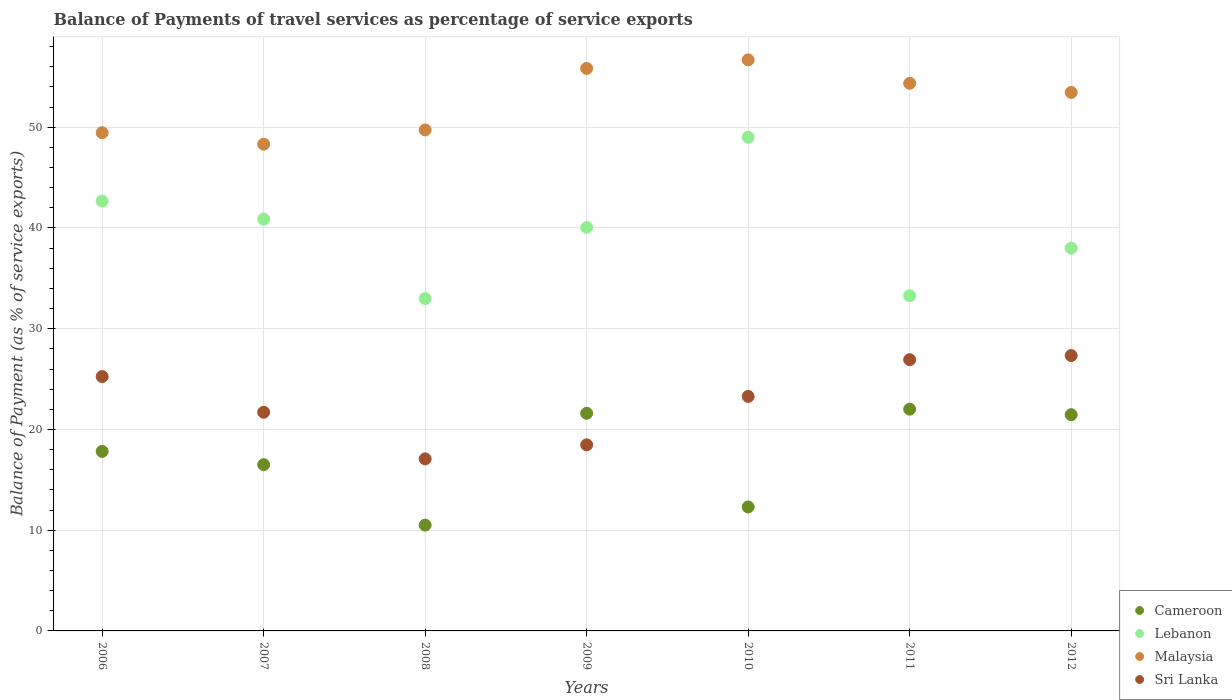How many different coloured dotlines are there?
Offer a terse response. 4. What is the balance of payments of travel services in Sri Lanka in 2008?
Your answer should be compact. 17.08. Across all years, what is the maximum balance of payments of travel services in Cameroon?
Offer a very short reply. 22.01. Across all years, what is the minimum balance of payments of travel services in Malaysia?
Offer a terse response. 48.32. In which year was the balance of payments of travel services in Cameroon maximum?
Give a very brief answer. 2011. In which year was the balance of payments of travel services in Malaysia minimum?
Offer a very short reply. 2007. What is the total balance of payments of travel services in Lebanon in the graph?
Provide a succinct answer. 276.89. What is the difference between the balance of payments of travel services in Malaysia in 2007 and that in 2010?
Keep it short and to the point. -8.37. What is the difference between the balance of payments of travel services in Malaysia in 2012 and the balance of payments of travel services in Cameroon in 2007?
Your response must be concise. 36.95. What is the average balance of payments of travel services in Lebanon per year?
Offer a terse response. 39.56. In the year 2011, what is the difference between the balance of payments of travel services in Malaysia and balance of payments of travel services in Cameroon?
Keep it short and to the point. 32.35. In how many years, is the balance of payments of travel services in Lebanon greater than 12 %?
Your answer should be very brief. 7. What is the ratio of the balance of payments of travel services in Sri Lanka in 2007 to that in 2012?
Offer a very short reply. 0.79. What is the difference between the highest and the second highest balance of payments of travel services in Malaysia?
Give a very brief answer. 0.85. What is the difference between the highest and the lowest balance of payments of travel services in Malaysia?
Offer a very short reply. 8.37. In how many years, is the balance of payments of travel services in Cameroon greater than the average balance of payments of travel services in Cameroon taken over all years?
Your answer should be compact. 4. Is the sum of the balance of payments of travel services in Cameroon in 2006 and 2012 greater than the maximum balance of payments of travel services in Sri Lanka across all years?
Give a very brief answer. Yes. Is it the case that in every year, the sum of the balance of payments of travel services in Malaysia and balance of payments of travel services in Lebanon  is greater than the sum of balance of payments of travel services in Cameroon and balance of payments of travel services in Sri Lanka?
Offer a very short reply. Yes. Is it the case that in every year, the sum of the balance of payments of travel services in Lebanon and balance of payments of travel services in Sri Lanka  is greater than the balance of payments of travel services in Malaysia?
Offer a very short reply. Yes. Is the balance of payments of travel services in Malaysia strictly greater than the balance of payments of travel services in Sri Lanka over the years?
Keep it short and to the point. Yes. Is the balance of payments of travel services in Sri Lanka strictly less than the balance of payments of travel services in Cameroon over the years?
Your answer should be very brief. No. How many dotlines are there?
Ensure brevity in your answer.  4. Are the values on the major ticks of Y-axis written in scientific E-notation?
Provide a short and direct response. No. Does the graph contain grids?
Offer a very short reply. Yes. How are the legend labels stacked?
Your response must be concise. Vertical. What is the title of the graph?
Provide a short and direct response. Balance of Payments of travel services as percentage of service exports. Does "High income: OECD" appear as one of the legend labels in the graph?
Your answer should be compact. No. What is the label or title of the Y-axis?
Make the answer very short. Balance of Payment (as % of service exports). What is the Balance of Payment (as % of service exports) in Cameroon in 2006?
Your response must be concise. 17.82. What is the Balance of Payment (as % of service exports) in Lebanon in 2006?
Your answer should be very brief. 42.68. What is the Balance of Payment (as % of service exports) of Malaysia in 2006?
Ensure brevity in your answer.  49.46. What is the Balance of Payment (as % of service exports) of Sri Lanka in 2006?
Your response must be concise. 25.25. What is the Balance of Payment (as % of service exports) of Cameroon in 2007?
Your response must be concise. 16.51. What is the Balance of Payment (as % of service exports) of Lebanon in 2007?
Your answer should be very brief. 40.89. What is the Balance of Payment (as % of service exports) of Malaysia in 2007?
Offer a terse response. 48.32. What is the Balance of Payment (as % of service exports) in Sri Lanka in 2007?
Your response must be concise. 21.71. What is the Balance of Payment (as % of service exports) in Cameroon in 2008?
Make the answer very short. 10.5. What is the Balance of Payment (as % of service exports) in Lebanon in 2008?
Keep it short and to the point. 33. What is the Balance of Payment (as % of service exports) in Malaysia in 2008?
Your response must be concise. 49.73. What is the Balance of Payment (as % of service exports) in Sri Lanka in 2008?
Provide a succinct answer. 17.08. What is the Balance of Payment (as % of service exports) in Cameroon in 2009?
Keep it short and to the point. 21.6. What is the Balance of Payment (as % of service exports) of Lebanon in 2009?
Offer a very short reply. 40.06. What is the Balance of Payment (as % of service exports) of Malaysia in 2009?
Give a very brief answer. 55.84. What is the Balance of Payment (as % of service exports) in Sri Lanka in 2009?
Your answer should be very brief. 18.47. What is the Balance of Payment (as % of service exports) of Cameroon in 2010?
Ensure brevity in your answer.  12.31. What is the Balance of Payment (as % of service exports) of Lebanon in 2010?
Give a very brief answer. 49.01. What is the Balance of Payment (as % of service exports) in Malaysia in 2010?
Make the answer very short. 56.69. What is the Balance of Payment (as % of service exports) in Sri Lanka in 2010?
Make the answer very short. 23.28. What is the Balance of Payment (as % of service exports) of Cameroon in 2011?
Give a very brief answer. 22.01. What is the Balance of Payment (as % of service exports) in Lebanon in 2011?
Your answer should be compact. 33.27. What is the Balance of Payment (as % of service exports) of Malaysia in 2011?
Provide a succinct answer. 54.36. What is the Balance of Payment (as % of service exports) of Sri Lanka in 2011?
Make the answer very short. 26.92. What is the Balance of Payment (as % of service exports) of Cameroon in 2012?
Provide a succinct answer. 21.46. What is the Balance of Payment (as % of service exports) in Lebanon in 2012?
Your answer should be compact. 38. What is the Balance of Payment (as % of service exports) of Malaysia in 2012?
Provide a short and direct response. 53.46. What is the Balance of Payment (as % of service exports) of Sri Lanka in 2012?
Your response must be concise. 27.34. Across all years, what is the maximum Balance of Payment (as % of service exports) in Cameroon?
Your answer should be compact. 22.01. Across all years, what is the maximum Balance of Payment (as % of service exports) of Lebanon?
Your response must be concise. 49.01. Across all years, what is the maximum Balance of Payment (as % of service exports) in Malaysia?
Your answer should be compact. 56.69. Across all years, what is the maximum Balance of Payment (as % of service exports) in Sri Lanka?
Keep it short and to the point. 27.34. Across all years, what is the minimum Balance of Payment (as % of service exports) of Cameroon?
Offer a very short reply. 10.5. Across all years, what is the minimum Balance of Payment (as % of service exports) of Lebanon?
Offer a very short reply. 33. Across all years, what is the minimum Balance of Payment (as % of service exports) in Malaysia?
Your answer should be very brief. 48.32. Across all years, what is the minimum Balance of Payment (as % of service exports) in Sri Lanka?
Provide a succinct answer. 17.08. What is the total Balance of Payment (as % of service exports) of Cameroon in the graph?
Offer a very short reply. 122.22. What is the total Balance of Payment (as % of service exports) of Lebanon in the graph?
Ensure brevity in your answer.  276.89. What is the total Balance of Payment (as % of service exports) of Malaysia in the graph?
Your answer should be compact. 367.86. What is the total Balance of Payment (as % of service exports) in Sri Lanka in the graph?
Give a very brief answer. 160.05. What is the difference between the Balance of Payment (as % of service exports) of Cameroon in 2006 and that in 2007?
Provide a short and direct response. 1.31. What is the difference between the Balance of Payment (as % of service exports) in Lebanon in 2006 and that in 2007?
Keep it short and to the point. 1.79. What is the difference between the Balance of Payment (as % of service exports) in Malaysia in 2006 and that in 2007?
Keep it short and to the point. 1.14. What is the difference between the Balance of Payment (as % of service exports) in Sri Lanka in 2006 and that in 2007?
Provide a short and direct response. 3.54. What is the difference between the Balance of Payment (as % of service exports) of Cameroon in 2006 and that in 2008?
Your answer should be very brief. 7.31. What is the difference between the Balance of Payment (as % of service exports) in Lebanon in 2006 and that in 2008?
Keep it short and to the point. 9.68. What is the difference between the Balance of Payment (as % of service exports) of Malaysia in 2006 and that in 2008?
Your answer should be compact. -0.27. What is the difference between the Balance of Payment (as % of service exports) in Sri Lanka in 2006 and that in 2008?
Keep it short and to the point. 8.17. What is the difference between the Balance of Payment (as % of service exports) in Cameroon in 2006 and that in 2009?
Offer a very short reply. -3.79. What is the difference between the Balance of Payment (as % of service exports) in Lebanon in 2006 and that in 2009?
Your answer should be very brief. 2.62. What is the difference between the Balance of Payment (as % of service exports) of Malaysia in 2006 and that in 2009?
Make the answer very short. -6.38. What is the difference between the Balance of Payment (as % of service exports) of Sri Lanka in 2006 and that in 2009?
Offer a terse response. 6.78. What is the difference between the Balance of Payment (as % of service exports) in Cameroon in 2006 and that in 2010?
Your answer should be compact. 5.51. What is the difference between the Balance of Payment (as % of service exports) of Lebanon in 2006 and that in 2010?
Offer a terse response. -6.33. What is the difference between the Balance of Payment (as % of service exports) in Malaysia in 2006 and that in 2010?
Your response must be concise. -7.23. What is the difference between the Balance of Payment (as % of service exports) of Sri Lanka in 2006 and that in 2010?
Keep it short and to the point. 1.97. What is the difference between the Balance of Payment (as % of service exports) in Cameroon in 2006 and that in 2011?
Provide a succinct answer. -4.2. What is the difference between the Balance of Payment (as % of service exports) of Lebanon in 2006 and that in 2011?
Make the answer very short. 9.41. What is the difference between the Balance of Payment (as % of service exports) in Malaysia in 2006 and that in 2011?
Offer a terse response. -4.9. What is the difference between the Balance of Payment (as % of service exports) of Sri Lanka in 2006 and that in 2011?
Your answer should be very brief. -1.67. What is the difference between the Balance of Payment (as % of service exports) of Cameroon in 2006 and that in 2012?
Your answer should be compact. -3.65. What is the difference between the Balance of Payment (as % of service exports) of Lebanon in 2006 and that in 2012?
Your answer should be compact. 4.68. What is the difference between the Balance of Payment (as % of service exports) in Malaysia in 2006 and that in 2012?
Your response must be concise. -3.99. What is the difference between the Balance of Payment (as % of service exports) of Sri Lanka in 2006 and that in 2012?
Provide a short and direct response. -2.09. What is the difference between the Balance of Payment (as % of service exports) in Cameroon in 2007 and that in 2008?
Keep it short and to the point. 6. What is the difference between the Balance of Payment (as % of service exports) of Lebanon in 2007 and that in 2008?
Ensure brevity in your answer.  7.89. What is the difference between the Balance of Payment (as % of service exports) of Malaysia in 2007 and that in 2008?
Offer a very short reply. -1.41. What is the difference between the Balance of Payment (as % of service exports) of Sri Lanka in 2007 and that in 2008?
Ensure brevity in your answer.  4.63. What is the difference between the Balance of Payment (as % of service exports) of Cameroon in 2007 and that in 2009?
Provide a succinct answer. -5.1. What is the difference between the Balance of Payment (as % of service exports) of Lebanon in 2007 and that in 2009?
Offer a very short reply. 0.83. What is the difference between the Balance of Payment (as % of service exports) in Malaysia in 2007 and that in 2009?
Ensure brevity in your answer.  -7.52. What is the difference between the Balance of Payment (as % of service exports) of Sri Lanka in 2007 and that in 2009?
Offer a terse response. 3.23. What is the difference between the Balance of Payment (as % of service exports) in Cameroon in 2007 and that in 2010?
Your answer should be compact. 4.2. What is the difference between the Balance of Payment (as % of service exports) of Lebanon in 2007 and that in 2010?
Make the answer very short. -8.12. What is the difference between the Balance of Payment (as % of service exports) of Malaysia in 2007 and that in 2010?
Offer a terse response. -8.37. What is the difference between the Balance of Payment (as % of service exports) in Sri Lanka in 2007 and that in 2010?
Your response must be concise. -1.57. What is the difference between the Balance of Payment (as % of service exports) of Cameroon in 2007 and that in 2011?
Provide a succinct answer. -5.51. What is the difference between the Balance of Payment (as % of service exports) in Lebanon in 2007 and that in 2011?
Offer a terse response. 7.62. What is the difference between the Balance of Payment (as % of service exports) of Malaysia in 2007 and that in 2011?
Keep it short and to the point. -6.04. What is the difference between the Balance of Payment (as % of service exports) in Sri Lanka in 2007 and that in 2011?
Provide a short and direct response. -5.22. What is the difference between the Balance of Payment (as % of service exports) in Cameroon in 2007 and that in 2012?
Make the answer very short. -4.96. What is the difference between the Balance of Payment (as % of service exports) of Lebanon in 2007 and that in 2012?
Make the answer very short. 2.89. What is the difference between the Balance of Payment (as % of service exports) of Malaysia in 2007 and that in 2012?
Offer a very short reply. -5.13. What is the difference between the Balance of Payment (as % of service exports) in Sri Lanka in 2007 and that in 2012?
Your answer should be compact. -5.63. What is the difference between the Balance of Payment (as % of service exports) of Cameroon in 2008 and that in 2009?
Your response must be concise. -11.1. What is the difference between the Balance of Payment (as % of service exports) of Lebanon in 2008 and that in 2009?
Provide a succinct answer. -7.06. What is the difference between the Balance of Payment (as % of service exports) in Malaysia in 2008 and that in 2009?
Ensure brevity in your answer.  -6.11. What is the difference between the Balance of Payment (as % of service exports) in Sri Lanka in 2008 and that in 2009?
Your answer should be very brief. -1.39. What is the difference between the Balance of Payment (as % of service exports) of Cameroon in 2008 and that in 2010?
Your answer should be compact. -1.8. What is the difference between the Balance of Payment (as % of service exports) in Lebanon in 2008 and that in 2010?
Offer a terse response. -16.01. What is the difference between the Balance of Payment (as % of service exports) of Malaysia in 2008 and that in 2010?
Offer a terse response. -6.96. What is the difference between the Balance of Payment (as % of service exports) in Sri Lanka in 2008 and that in 2010?
Make the answer very short. -6.2. What is the difference between the Balance of Payment (as % of service exports) in Cameroon in 2008 and that in 2011?
Your response must be concise. -11.51. What is the difference between the Balance of Payment (as % of service exports) of Lebanon in 2008 and that in 2011?
Make the answer very short. -0.27. What is the difference between the Balance of Payment (as % of service exports) of Malaysia in 2008 and that in 2011?
Offer a terse response. -4.63. What is the difference between the Balance of Payment (as % of service exports) of Sri Lanka in 2008 and that in 2011?
Give a very brief answer. -9.84. What is the difference between the Balance of Payment (as % of service exports) of Cameroon in 2008 and that in 2012?
Provide a short and direct response. -10.96. What is the difference between the Balance of Payment (as % of service exports) of Lebanon in 2008 and that in 2012?
Make the answer very short. -5. What is the difference between the Balance of Payment (as % of service exports) of Malaysia in 2008 and that in 2012?
Keep it short and to the point. -3.72. What is the difference between the Balance of Payment (as % of service exports) of Sri Lanka in 2008 and that in 2012?
Provide a succinct answer. -10.26. What is the difference between the Balance of Payment (as % of service exports) in Cameroon in 2009 and that in 2010?
Provide a succinct answer. 9.3. What is the difference between the Balance of Payment (as % of service exports) in Lebanon in 2009 and that in 2010?
Your answer should be compact. -8.95. What is the difference between the Balance of Payment (as % of service exports) of Malaysia in 2009 and that in 2010?
Keep it short and to the point. -0.85. What is the difference between the Balance of Payment (as % of service exports) of Sri Lanka in 2009 and that in 2010?
Ensure brevity in your answer.  -4.8. What is the difference between the Balance of Payment (as % of service exports) of Cameroon in 2009 and that in 2011?
Provide a succinct answer. -0.41. What is the difference between the Balance of Payment (as % of service exports) of Lebanon in 2009 and that in 2011?
Ensure brevity in your answer.  6.79. What is the difference between the Balance of Payment (as % of service exports) of Malaysia in 2009 and that in 2011?
Keep it short and to the point. 1.48. What is the difference between the Balance of Payment (as % of service exports) of Sri Lanka in 2009 and that in 2011?
Offer a terse response. -8.45. What is the difference between the Balance of Payment (as % of service exports) of Cameroon in 2009 and that in 2012?
Provide a succinct answer. 0.14. What is the difference between the Balance of Payment (as % of service exports) in Lebanon in 2009 and that in 2012?
Provide a short and direct response. 2.06. What is the difference between the Balance of Payment (as % of service exports) in Malaysia in 2009 and that in 2012?
Provide a succinct answer. 2.38. What is the difference between the Balance of Payment (as % of service exports) in Sri Lanka in 2009 and that in 2012?
Make the answer very short. -8.86. What is the difference between the Balance of Payment (as % of service exports) of Cameroon in 2010 and that in 2011?
Offer a terse response. -9.71. What is the difference between the Balance of Payment (as % of service exports) in Lebanon in 2010 and that in 2011?
Ensure brevity in your answer.  15.74. What is the difference between the Balance of Payment (as % of service exports) of Malaysia in 2010 and that in 2011?
Offer a very short reply. 2.33. What is the difference between the Balance of Payment (as % of service exports) in Sri Lanka in 2010 and that in 2011?
Provide a succinct answer. -3.65. What is the difference between the Balance of Payment (as % of service exports) of Cameroon in 2010 and that in 2012?
Your answer should be very brief. -9.16. What is the difference between the Balance of Payment (as % of service exports) in Lebanon in 2010 and that in 2012?
Keep it short and to the point. 11.01. What is the difference between the Balance of Payment (as % of service exports) of Malaysia in 2010 and that in 2012?
Your answer should be compact. 3.24. What is the difference between the Balance of Payment (as % of service exports) of Sri Lanka in 2010 and that in 2012?
Ensure brevity in your answer.  -4.06. What is the difference between the Balance of Payment (as % of service exports) of Cameroon in 2011 and that in 2012?
Make the answer very short. 0.55. What is the difference between the Balance of Payment (as % of service exports) in Lebanon in 2011 and that in 2012?
Offer a very short reply. -4.73. What is the difference between the Balance of Payment (as % of service exports) of Malaysia in 2011 and that in 2012?
Provide a succinct answer. 0.91. What is the difference between the Balance of Payment (as % of service exports) of Sri Lanka in 2011 and that in 2012?
Offer a terse response. -0.41. What is the difference between the Balance of Payment (as % of service exports) in Cameroon in 2006 and the Balance of Payment (as % of service exports) in Lebanon in 2007?
Provide a succinct answer. -23.07. What is the difference between the Balance of Payment (as % of service exports) in Cameroon in 2006 and the Balance of Payment (as % of service exports) in Malaysia in 2007?
Your response must be concise. -30.5. What is the difference between the Balance of Payment (as % of service exports) of Cameroon in 2006 and the Balance of Payment (as % of service exports) of Sri Lanka in 2007?
Offer a terse response. -3.89. What is the difference between the Balance of Payment (as % of service exports) of Lebanon in 2006 and the Balance of Payment (as % of service exports) of Malaysia in 2007?
Your answer should be very brief. -5.65. What is the difference between the Balance of Payment (as % of service exports) of Lebanon in 2006 and the Balance of Payment (as % of service exports) of Sri Lanka in 2007?
Your answer should be very brief. 20.97. What is the difference between the Balance of Payment (as % of service exports) of Malaysia in 2006 and the Balance of Payment (as % of service exports) of Sri Lanka in 2007?
Make the answer very short. 27.75. What is the difference between the Balance of Payment (as % of service exports) in Cameroon in 2006 and the Balance of Payment (as % of service exports) in Lebanon in 2008?
Provide a succinct answer. -15.18. What is the difference between the Balance of Payment (as % of service exports) of Cameroon in 2006 and the Balance of Payment (as % of service exports) of Malaysia in 2008?
Offer a very short reply. -31.91. What is the difference between the Balance of Payment (as % of service exports) in Cameroon in 2006 and the Balance of Payment (as % of service exports) in Sri Lanka in 2008?
Provide a succinct answer. 0.74. What is the difference between the Balance of Payment (as % of service exports) of Lebanon in 2006 and the Balance of Payment (as % of service exports) of Malaysia in 2008?
Make the answer very short. -7.06. What is the difference between the Balance of Payment (as % of service exports) of Lebanon in 2006 and the Balance of Payment (as % of service exports) of Sri Lanka in 2008?
Provide a succinct answer. 25.6. What is the difference between the Balance of Payment (as % of service exports) in Malaysia in 2006 and the Balance of Payment (as % of service exports) in Sri Lanka in 2008?
Make the answer very short. 32.38. What is the difference between the Balance of Payment (as % of service exports) of Cameroon in 2006 and the Balance of Payment (as % of service exports) of Lebanon in 2009?
Your answer should be very brief. -22.24. What is the difference between the Balance of Payment (as % of service exports) of Cameroon in 2006 and the Balance of Payment (as % of service exports) of Malaysia in 2009?
Offer a terse response. -38.02. What is the difference between the Balance of Payment (as % of service exports) of Cameroon in 2006 and the Balance of Payment (as % of service exports) of Sri Lanka in 2009?
Ensure brevity in your answer.  -0.66. What is the difference between the Balance of Payment (as % of service exports) in Lebanon in 2006 and the Balance of Payment (as % of service exports) in Malaysia in 2009?
Offer a terse response. -13.16. What is the difference between the Balance of Payment (as % of service exports) of Lebanon in 2006 and the Balance of Payment (as % of service exports) of Sri Lanka in 2009?
Give a very brief answer. 24.2. What is the difference between the Balance of Payment (as % of service exports) in Malaysia in 2006 and the Balance of Payment (as % of service exports) in Sri Lanka in 2009?
Your answer should be compact. 30.99. What is the difference between the Balance of Payment (as % of service exports) in Cameroon in 2006 and the Balance of Payment (as % of service exports) in Lebanon in 2010?
Provide a short and direct response. -31.19. What is the difference between the Balance of Payment (as % of service exports) in Cameroon in 2006 and the Balance of Payment (as % of service exports) in Malaysia in 2010?
Your answer should be compact. -38.87. What is the difference between the Balance of Payment (as % of service exports) in Cameroon in 2006 and the Balance of Payment (as % of service exports) in Sri Lanka in 2010?
Offer a terse response. -5.46. What is the difference between the Balance of Payment (as % of service exports) of Lebanon in 2006 and the Balance of Payment (as % of service exports) of Malaysia in 2010?
Offer a terse response. -14.02. What is the difference between the Balance of Payment (as % of service exports) in Lebanon in 2006 and the Balance of Payment (as % of service exports) in Sri Lanka in 2010?
Give a very brief answer. 19.4. What is the difference between the Balance of Payment (as % of service exports) of Malaysia in 2006 and the Balance of Payment (as % of service exports) of Sri Lanka in 2010?
Keep it short and to the point. 26.18. What is the difference between the Balance of Payment (as % of service exports) of Cameroon in 2006 and the Balance of Payment (as % of service exports) of Lebanon in 2011?
Give a very brief answer. -15.45. What is the difference between the Balance of Payment (as % of service exports) in Cameroon in 2006 and the Balance of Payment (as % of service exports) in Malaysia in 2011?
Give a very brief answer. -36.54. What is the difference between the Balance of Payment (as % of service exports) of Cameroon in 2006 and the Balance of Payment (as % of service exports) of Sri Lanka in 2011?
Provide a short and direct response. -9.11. What is the difference between the Balance of Payment (as % of service exports) in Lebanon in 2006 and the Balance of Payment (as % of service exports) in Malaysia in 2011?
Provide a succinct answer. -11.69. What is the difference between the Balance of Payment (as % of service exports) in Lebanon in 2006 and the Balance of Payment (as % of service exports) in Sri Lanka in 2011?
Your answer should be compact. 15.75. What is the difference between the Balance of Payment (as % of service exports) in Malaysia in 2006 and the Balance of Payment (as % of service exports) in Sri Lanka in 2011?
Your answer should be very brief. 22.54. What is the difference between the Balance of Payment (as % of service exports) in Cameroon in 2006 and the Balance of Payment (as % of service exports) in Lebanon in 2012?
Keep it short and to the point. -20.18. What is the difference between the Balance of Payment (as % of service exports) in Cameroon in 2006 and the Balance of Payment (as % of service exports) in Malaysia in 2012?
Your response must be concise. -35.64. What is the difference between the Balance of Payment (as % of service exports) in Cameroon in 2006 and the Balance of Payment (as % of service exports) in Sri Lanka in 2012?
Provide a succinct answer. -9.52. What is the difference between the Balance of Payment (as % of service exports) in Lebanon in 2006 and the Balance of Payment (as % of service exports) in Malaysia in 2012?
Your response must be concise. -10.78. What is the difference between the Balance of Payment (as % of service exports) in Lebanon in 2006 and the Balance of Payment (as % of service exports) in Sri Lanka in 2012?
Your response must be concise. 15.34. What is the difference between the Balance of Payment (as % of service exports) of Malaysia in 2006 and the Balance of Payment (as % of service exports) of Sri Lanka in 2012?
Your answer should be compact. 22.13. What is the difference between the Balance of Payment (as % of service exports) of Cameroon in 2007 and the Balance of Payment (as % of service exports) of Lebanon in 2008?
Ensure brevity in your answer.  -16.49. What is the difference between the Balance of Payment (as % of service exports) in Cameroon in 2007 and the Balance of Payment (as % of service exports) in Malaysia in 2008?
Offer a terse response. -33.22. What is the difference between the Balance of Payment (as % of service exports) of Cameroon in 2007 and the Balance of Payment (as % of service exports) of Sri Lanka in 2008?
Provide a short and direct response. -0.57. What is the difference between the Balance of Payment (as % of service exports) in Lebanon in 2007 and the Balance of Payment (as % of service exports) in Malaysia in 2008?
Your answer should be compact. -8.85. What is the difference between the Balance of Payment (as % of service exports) of Lebanon in 2007 and the Balance of Payment (as % of service exports) of Sri Lanka in 2008?
Offer a very short reply. 23.81. What is the difference between the Balance of Payment (as % of service exports) in Malaysia in 2007 and the Balance of Payment (as % of service exports) in Sri Lanka in 2008?
Make the answer very short. 31.24. What is the difference between the Balance of Payment (as % of service exports) of Cameroon in 2007 and the Balance of Payment (as % of service exports) of Lebanon in 2009?
Provide a succinct answer. -23.55. What is the difference between the Balance of Payment (as % of service exports) of Cameroon in 2007 and the Balance of Payment (as % of service exports) of Malaysia in 2009?
Your response must be concise. -39.33. What is the difference between the Balance of Payment (as % of service exports) in Cameroon in 2007 and the Balance of Payment (as % of service exports) in Sri Lanka in 2009?
Keep it short and to the point. -1.97. What is the difference between the Balance of Payment (as % of service exports) of Lebanon in 2007 and the Balance of Payment (as % of service exports) of Malaysia in 2009?
Your answer should be compact. -14.95. What is the difference between the Balance of Payment (as % of service exports) in Lebanon in 2007 and the Balance of Payment (as % of service exports) in Sri Lanka in 2009?
Ensure brevity in your answer.  22.41. What is the difference between the Balance of Payment (as % of service exports) of Malaysia in 2007 and the Balance of Payment (as % of service exports) of Sri Lanka in 2009?
Provide a succinct answer. 29.85. What is the difference between the Balance of Payment (as % of service exports) of Cameroon in 2007 and the Balance of Payment (as % of service exports) of Lebanon in 2010?
Keep it short and to the point. -32.5. What is the difference between the Balance of Payment (as % of service exports) of Cameroon in 2007 and the Balance of Payment (as % of service exports) of Malaysia in 2010?
Give a very brief answer. -40.18. What is the difference between the Balance of Payment (as % of service exports) in Cameroon in 2007 and the Balance of Payment (as % of service exports) in Sri Lanka in 2010?
Ensure brevity in your answer.  -6.77. What is the difference between the Balance of Payment (as % of service exports) of Lebanon in 2007 and the Balance of Payment (as % of service exports) of Malaysia in 2010?
Give a very brief answer. -15.81. What is the difference between the Balance of Payment (as % of service exports) in Lebanon in 2007 and the Balance of Payment (as % of service exports) in Sri Lanka in 2010?
Make the answer very short. 17.61. What is the difference between the Balance of Payment (as % of service exports) of Malaysia in 2007 and the Balance of Payment (as % of service exports) of Sri Lanka in 2010?
Give a very brief answer. 25.04. What is the difference between the Balance of Payment (as % of service exports) in Cameroon in 2007 and the Balance of Payment (as % of service exports) in Lebanon in 2011?
Provide a succinct answer. -16.76. What is the difference between the Balance of Payment (as % of service exports) of Cameroon in 2007 and the Balance of Payment (as % of service exports) of Malaysia in 2011?
Keep it short and to the point. -37.85. What is the difference between the Balance of Payment (as % of service exports) of Cameroon in 2007 and the Balance of Payment (as % of service exports) of Sri Lanka in 2011?
Offer a terse response. -10.42. What is the difference between the Balance of Payment (as % of service exports) in Lebanon in 2007 and the Balance of Payment (as % of service exports) in Malaysia in 2011?
Give a very brief answer. -13.48. What is the difference between the Balance of Payment (as % of service exports) of Lebanon in 2007 and the Balance of Payment (as % of service exports) of Sri Lanka in 2011?
Offer a very short reply. 13.96. What is the difference between the Balance of Payment (as % of service exports) of Malaysia in 2007 and the Balance of Payment (as % of service exports) of Sri Lanka in 2011?
Your answer should be very brief. 21.4. What is the difference between the Balance of Payment (as % of service exports) in Cameroon in 2007 and the Balance of Payment (as % of service exports) in Lebanon in 2012?
Provide a succinct answer. -21.49. What is the difference between the Balance of Payment (as % of service exports) in Cameroon in 2007 and the Balance of Payment (as % of service exports) in Malaysia in 2012?
Make the answer very short. -36.95. What is the difference between the Balance of Payment (as % of service exports) in Cameroon in 2007 and the Balance of Payment (as % of service exports) in Sri Lanka in 2012?
Provide a succinct answer. -10.83. What is the difference between the Balance of Payment (as % of service exports) in Lebanon in 2007 and the Balance of Payment (as % of service exports) in Malaysia in 2012?
Offer a terse response. -12.57. What is the difference between the Balance of Payment (as % of service exports) of Lebanon in 2007 and the Balance of Payment (as % of service exports) of Sri Lanka in 2012?
Provide a short and direct response. 13.55. What is the difference between the Balance of Payment (as % of service exports) of Malaysia in 2007 and the Balance of Payment (as % of service exports) of Sri Lanka in 2012?
Provide a short and direct response. 20.98. What is the difference between the Balance of Payment (as % of service exports) in Cameroon in 2008 and the Balance of Payment (as % of service exports) in Lebanon in 2009?
Keep it short and to the point. -29.56. What is the difference between the Balance of Payment (as % of service exports) in Cameroon in 2008 and the Balance of Payment (as % of service exports) in Malaysia in 2009?
Provide a short and direct response. -45.34. What is the difference between the Balance of Payment (as % of service exports) in Cameroon in 2008 and the Balance of Payment (as % of service exports) in Sri Lanka in 2009?
Give a very brief answer. -7.97. What is the difference between the Balance of Payment (as % of service exports) of Lebanon in 2008 and the Balance of Payment (as % of service exports) of Malaysia in 2009?
Provide a succinct answer. -22.84. What is the difference between the Balance of Payment (as % of service exports) of Lebanon in 2008 and the Balance of Payment (as % of service exports) of Sri Lanka in 2009?
Offer a very short reply. 14.52. What is the difference between the Balance of Payment (as % of service exports) of Malaysia in 2008 and the Balance of Payment (as % of service exports) of Sri Lanka in 2009?
Your answer should be compact. 31.26. What is the difference between the Balance of Payment (as % of service exports) in Cameroon in 2008 and the Balance of Payment (as % of service exports) in Lebanon in 2010?
Offer a very short reply. -38.5. What is the difference between the Balance of Payment (as % of service exports) of Cameroon in 2008 and the Balance of Payment (as % of service exports) of Malaysia in 2010?
Provide a short and direct response. -46.19. What is the difference between the Balance of Payment (as % of service exports) in Cameroon in 2008 and the Balance of Payment (as % of service exports) in Sri Lanka in 2010?
Give a very brief answer. -12.77. What is the difference between the Balance of Payment (as % of service exports) of Lebanon in 2008 and the Balance of Payment (as % of service exports) of Malaysia in 2010?
Offer a very short reply. -23.7. What is the difference between the Balance of Payment (as % of service exports) in Lebanon in 2008 and the Balance of Payment (as % of service exports) in Sri Lanka in 2010?
Offer a very short reply. 9.72. What is the difference between the Balance of Payment (as % of service exports) in Malaysia in 2008 and the Balance of Payment (as % of service exports) in Sri Lanka in 2010?
Provide a short and direct response. 26.45. What is the difference between the Balance of Payment (as % of service exports) of Cameroon in 2008 and the Balance of Payment (as % of service exports) of Lebanon in 2011?
Give a very brief answer. -22.76. What is the difference between the Balance of Payment (as % of service exports) of Cameroon in 2008 and the Balance of Payment (as % of service exports) of Malaysia in 2011?
Provide a short and direct response. -43.86. What is the difference between the Balance of Payment (as % of service exports) in Cameroon in 2008 and the Balance of Payment (as % of service exports) in Sri Lanka in 2011?
Your response must be concise. -16.42. What is the difference between the Balance of Payment (as % of service exports) of Lebanon in 2008 and the Balance of Payment (as % of service exports) of Malaysia in 2011?
Provide a succinct answer. -21.37. What is the difference between the Balance of Payment (as % of service exports) of Lebanon in 2008 and the Balance of Payment (as % of service exports) of Sri Lanka in 2011?
Keep it short and to the point. 6.07. What is the difference between the Balance of Payment (as % of service exports) in Malaysia in 2008 and the Balance of Payment (as % of service exports) in Sri Lanka in 2011?
Your answer should be very brief. 22.81. What is the difference between the Balance of Payment (as % of service exports) of Cameroon in 2008 and the Balance of Payment (as % of service exports) of Lebanon in 2012?
Your response must be concise. -27.5. What is the difference between the Balance of Payment (as % of service exports) of Cameroon in 2008 and the Balance of Payment (as % of service exports) of Malaysia in 2012?
Keep it short and to the point. -42.95. What is the difference between the Balance of Payment (as % of service exports) of Cameroon in 2008 and the Balance of Payment (as % of service exports) of Sri Lanka in 2012?
Your response must be concise. -16.83. What is the difference between the Balance of Payment (as % of service exports) of Lebanon in 2008 and the Balance of Payment (as % of service exports) of Malaysia in 2012?
Give a very brief answer. -20.46. What is the difference between the Balance of Payment (as % of service exports) of Lebanon in 2008 and the Balance of Payment (as % of service exports) of Sri Lanka in 2012?
Offer a very short reply. 5.66. What is the difference between the Balance of Payment (as % of service exports) of Malaysia in 2008 and the Balance of Payment (as % of service exports) of Sri Lanka in 2012?
Offer a very short reply. 22.4. What is the difference between the Balance of Payment (as % of service exports) of Cameroon in 2009 and the Balance of Payment (as % of service exports) of Lebanon in 2010?
Make the answer very short. -27.4. What is the difference between the Balance of Payment (as % of service exports) of Cameroon in 2009 and the Balance of Payment (as % of service exports) of Malaysia in 2010?
Provide a succinct answer. -35.09. What is the difference between the Balance of Payment (as % of service exports) of Cameroon in 2009 and the Balance of Payment (as % of service exports) of Sri Lanka in 2010?
Your answer should be compact. -1.67. What is the difference between the Balance of Payment (as % of service exports) in Lebanon in 2009 and the Balance of Payment (as % of service exports) in Malaysia in 2010?
Keep it short and to the point. -16.63. What is the difference between the Balance of Payment (as % of service exports) of Lebanon in 2009 and the Balance of Payment (as % of service exports) of Sri Lanka in 2010?
Make the answer very short. 16.78. What is the difference between the Balance of Payment (as % of service exports) in Malaysia in 2009 and the Balance of Payment (as % of service exports) in Sri Lanka in 2010?
Your answer should be very brief. 32.56. What is the difference between the Balance of Payment (as % of service exports) of Cameroon in 2009 and the Balance of Payment (as % of service exports) of Lebanon in 2011?
Your answer should be compact. -11.66. What is the difference between the Balance of Payment (as % of service exports) of Cameroon in 2009 and the Balance of Payment (as % of service exports) of Malaysia in 2011?
Your answer should be very brief. -32.76. What is the difference between the Balance of Payment (as % of service exports) of Cameroon in 2009 and the Balance of Payment (as % of service exports) of Sri Lanka in 2011?
Your response must be concise. -5.32. What is the difference between the Balance of Payment (as % of service exports) of Lebanon in 2009 and the Balance of Payment (as % of service exports) of Malaysia in 2011?
Your answer should be very brief. -14.3. What is the difference between the Balance of Payment (as % of service exports) in Lebanon in 2009 and the Balance of Payment (as % of service exports) in Sri Lanka in 2011?
Ensure brevity in your answer.  13.14. What is the difference between the Balance of Payment (as % of service exports) in Malaysia in 2009 and the Balance of Payment (as % of service exports) in Sri Lanka in 2011?
Your answer should be compact. 28.91. What is the difference between the Balance of Payment (as % of service exports) in Cameroon in 2009 and the Balance of Payment (as % of service exports) in Lebanon in 2012?
Your answer should be compact. -16.4. What is the difference between the Balance of Payment (as % of service exports) in Cameroon in 2009 and the Balance of Payment (as % of service exports) in Malaysia in 2012?
Keep it short and to the point. -31.85. What is the difference between the Balance of Payment (as % of service exports) in Cameroon in 2009 and the Balance of Payment (as % of service exports) in Sri Lanka in 2012?
Provide a short and direct response. -5.73. What is the difference between the Balance of Payment (as % of service exports) of Lebanon in 2009 and the Balance of Payment (as % of service exports) of Malaysia in 2012?
Provide a short and direct response. -13.4. What is the difference between the Balance of Payment (as % of service exports) in Lebanon in 2009 and the Balance of Payment (as % of service exports) in Sri Lanka in 2012?
Provide a succinct answer. 12.72. What is the difference between the Balance of Payment (as % of service exports) in Malaysia in 2009 and the Balance of Payment (as % of service exports) in Sri Lanka in 2012?
Offer a very short reply. 28.5. What is the difference between the Balance of Payment (as % of service exports) of Cameroon in 2010 and the Balance of Payment (as % of service exports) of Lebanon in 2011?
Make the answer very short. -20.96. What is the difference between the Balance of Payment (as % of service exports) in Cameroon in 2010 and the Balance of Payment (as % of service exports) in Malaysia in 2011?
Offer a terse response. -42.05. What is the difference between the Balance of Payment (as % of service exports) in Cameroon in 2010 and the Balance of Payment (as % of service exports) in Sri Lanka in 2011?
Provide a short and direct response. -14.62. What is the difference between the Balance of Payment (as % of service exports) of Lebanon in 2010 and the Balance of Payment (as % of service exports) of Malaysia in 2011?
Your response must be concise. -5.36. What is the difference between the Balance of Payment (as % of service exports) in Lebanon in 2010 and the Balance of Payment (as % of service exports) in Sri Lanka in 2011?
Make the answer very short. 22.08. What is the difference between the Balance of Payment (as % of service exports) of Malaysia in 2010 and the Balance of Payment (as % of service exports) of Sri Lanka in 2011?
Provide a succinct answer. 29.77. What is the difference between the Balance of Payment (as % of service exports) of Cameroon in 2010 and the Balance of Payment (as % of service exports) of Lebanon in 2012?
Give a very brief answer. -25.69. What is the difference between the Balance of Payment (as % of service exports) of Cameroon in 2010 and the Balance of Payment (as % of service exports) of Malaysia in 2012?
Keep it short and to the point. -41.15. What is the difference between the Balance of Payment (as % of service exports) of Cameroon in 2010 and the Balance of Payment (as % of service exports) of Sri Lanka in 2012?
Offer a very short reply. -15.03. What is the difference between the Balance of Payment (as % of service exports) in Lebanon in 2010 and the Balance of Payment (as % of service exports) in Malaysia in 2012?
Offer a terse response. -4.45. What is the difference between the Balance of Payment (as % of service exports) of Lebanon in 2010 and the Balance of Payment (as % of service exports) of Sri Lanka in 2012?
Keep it short and to the point. 21.67. What is the difference between the Balance of Payment (as % of service exports) in Malaysia in 2010 and the Balance of Payment (as % of service exports) in Sri Lanka in 2012?
Keep it short and to the point. 29.36. What is the difference between the Balance of Payment (as % of service exports) of Cameroon in 2011 and the Balance of Payment (as % of service exports) of Lebanon in 2012?
Keep it short and to the point. -15.99. What is the difference between the Balance of Payment (as % of service exports) in Cameroon in 2011 and the Balance of Payment (as % of service exports) in Malaysia in 2012?
Your answer should be very brief. -31.44. What is the difference between the Balance of Payment (as % of service exports) of Cameroon in 2011 and the Balance of Payment (as % of service exports) of Sri Lanka in 2012?
Keep it short and to the point. -5.32. What is the difference between the Balance of Payment (as % of service exports) of Lebanon in 2011 and the Balance of Payment (as % of service exports) of Malaysia in 2012?
Provide a short and direct response. -20.19. What is the difference between the Balance of Payment (as % of service exports) of Lebanon in 2011 and the Balance of Payment (as % of service exports) of Sri Lanka in 2012?
Offer a very short reply. 5.93. What is the difference between the Balance of Payment (as % of service exports) in Malaysia in 2011 and the Balance of Payment (as % of service exports) in Sri Lanka in 2012?
Offer a very short reply. 27.03. What is the average Balance of Payment (as % of service exports) in Cameroon per year?
Provide a succinct answer. 17.46. What is the average Balance of Payment (as % of service exports) of Lebanon per year?
Make the answer very short. 39.56. What is the average Balance of Payment (as % of service exports) of Malaysia per year?
Give a very brief answer. 52.55. What is the average Balance of Payment (as % of service exports) in Sri Lanka per year?
Give a very brief answer. 22.86. In the year 2006, what is the difference between the Balance of Payment (as % of service exports) of Cameroon and Balance of Payment (as % of service exports) of Lebanon?
Keep it short and to the point. -24.86. In the year 2006, what is the difference between the Balance of Payment (as % of service exports) of Cameroon and Balance of Payment (as % of service exports) of Malaysia?
Keep it short and to the point. -31.64. In the year 2006, what is the difference between the Balance of Payment (as % of service exports) in Cameroon and Balance of Payment (as % of service exports) in Sri Lanka?
Offer a very short reply. -7.43. In the year 2006, what is the difference between the Balance of Payment (as % of service exports) in Lebanon and Balance of Payment (as % of service exports) in Malaysia?
Offer a terse response. -6.79. In the year 2006, what is the difference between the Balance of Payment (as % of service exports) of Lebanon and Balance of Payment (as % of service exports) of Sri Lanka?
Provide a short and direct response. 17.42. In the year 2006, what is the difference between the Balance of Payment (as % of service exports) in Malaysia and Balance of Payment (as % of service exports) in Sri Lanka?
Your answer should be very brief. 24.21. In the year 2007, what is the difference between the Balance of Payment (as % of service exports) of Cameroon and Balance of Payment (as % of service exports) of Lebanon?
Ensure brevity in your answer.  -24.38. In the year 2007, what is the difference between the Balance of Payment (as % of service exports) in Cameroon and Balance of Payment (as % of service exports) in Malaysia?
Make the answer very short. -31.81. In the year 2007, what is the difference between the Balance of Payment (as % of service exports) in Cameroon and Balance of Payment (as % of service exports) in Sri Lanka?
Give a very brief answer. -5.2. In the year 2007, what is the difference between the Balance of Payment (as % of service exports) of Lebanon and Balance of Payment (as % of service exports) of Malaysia?
Offer a terse response. -7.44. In the year 2007, what is the difference between the Balance of Payment (as % of service exports) of Lebanon and Balance of Payment (as % of service exports) of Sri Lanka?
Keep it short and to the point. 19.18. In the year 2007, what is the difference between the Balance of Payment (as % of service exports) of Malaysia and Balance of Payment (as % of service exports) of Sri Lanka?
Your answer should be compact. 26.61. In the year 2008, what is the difference between the Balance of Payment (as % of service exports) in Cameroon and Balance of Payment (as % of service exports) in Lebanon?
Your answer should be very brief. -22.49. In the year 2008, what is the difference between the Balance of Payment (as % of service exports) of Cameroon and Balance of Payment (as % of service exports) of Malaysia?
Your answer should be compact. -39.23. In the year 2008, what is the difference between the Balance of Payment (as % of service exports) in Cameroon and Balance of Payment (as % of service exports) in Sri Lanka?
Make the answer very short. -6.58. In the year 2008, what is the difference between the Balance of Payment (as % of service exports) of Lebanon and Balance of Payment (as % of service exports) of Malaysia?
Offer a terse response. -16.74. In the year 2008, what is the difference between the Balance of Payment (as % of service exports) in Lebanon and Balance of Payment (as % of service exports) in Sri Lanka?
Provide a short and direct response. 15.92. In the year 2008, what is the difference between the Balance of Payment (as % of service exports) in Malaysia and Balance of Payment (as % of service exports) in Sri Lanka?
Keep it short and to the point. 32.65. In the year 2009, what is the difference between the Balance of Payment (as % of service exports) in Cameroon and Balance of Payment (as % of service exports) in Lebanon?
Give a very brief answer. -18.46. In the year 2009, what is the difference between the Balance of Payment (as % of service exports) in Cameroon and Balance of Payment (as % of service exports) in Malaysia?
Offer a very short reply. -34.23. In the year 2009, what is the difference between the Balance of Payment (as % of service exports) of Cameroon and Balance of Payment (as % of service exports) of Sri Lanka?
Provide a succinct answer. 3.13. In the year 2009, what is the difference between the Balance of Payment (as % of service exports) in Lebanon and Balance of Payment (as % of service exports) in Malaysia?
Offer a terse response. -15.78. In the year 2009, what is the difference between the Balance of Payment (as % of service exports) in Lebanon and Balance of Payment (as % of service exports) in Sri Lanka?
Your answer should be very brief. 21.59. In the year 2009, what is the difference between the Balance of Payment (as % of service exports) of Malaysia and Balance of Payment (as % of service exports) of Sri Lanka?
Provide a short and direct response. 37.36. In the year 2010, what is the difference between the Balance of Payment (as % of service exports) in Cameroon and Balance of Payment (as % of service exports) in Lebanon?
Offer a terse response. -36.7. In the year 2010, what is the difference between the Balance of Payment (as % of service exports) of Cameroon and Balance of Payment (as % of service exports) of Malaysia?
Your answer should be very brief. -44.38. In the year 2010, what is the difference between the Balance of Payment (as % of service exports) of Cameroon and Balance of Payment (as % of service exports) of Sri Lanka?
Ensure brevity in your answer.  -10.97. In the year 2010, what is the difference between the Balance of Payment (as % of service exports) of Lebanon and Balance of Payment (as % of service exports) of Malaysia?
Provide a short and direct response. -7.68. In the year 2010, what is the difference between the Balance of Payment (as % of service exports) in Lebanon and Balance of Payment (as % of service exports) in Sri Lanka?
Your response must be concise. 25.73. In the year 2010, what is the difference between the Balance of Payment (as % of service exports) of Malaysia and Balance of Payment (as % of service exports) of Sri Lanka?
Ensure brevity in your answer.  33.41. In the year 2011, what is the difference between the Balance of Payment (as % of service exports) of Cameroon and Balance of Payment (as % of service exports) of Lebanon?
Make the answer very short. -11.25. In the year 2011, what is the difference between the Balance of Payment (as % of service exports) of Cameroon and Balance of Payment (as % of service exports) of Malaysia?
Your answer should be very brief. -32.35. In the year 2011, what is the difference between the Balance of Payment (as % of service exports) of Cameroon and Balance of Payment (as % of service exports) of Sri Lanka?
Give a very brief answer. -4.91. In the year 2011, what is the difference between the Balance of Payment (as % of service exports) of Lebanon and Balance of Payment (as % of service exports) of Malaysia?
Make the answer very short. -21.09. In the year 2011, what is the difference between the Balance of Payment (as % of service exports) of Lebanon and Balance of Payment (as % of service exports) of Sri Lanka?
Make the answer very short. 6.34. In the year 2011, what is the difference between the Balance of Payment (as % of service exports) of Malaysia and Balance of Payment (as % of service exports) of Sri Lanka?
Ensure brevity in your answer.  27.44. In the year 2012, what is the difference between the Balance of Payment (as % of service exports) of Cameroon and Balance of Payment (as % of service exports) of Lebanon?
Offer a terse response. -16.53. In the year 2012, what is the difference between the Balance of Payment (as % of service exports) of Cameroon and Balance of Payment (as % of service exports) of Malaysia?
Offer a very short reply. -31.99. In the year 2012, what is the difference between the Balance of Payment (as % of service exports) of Cameroon and Balance of Payment (as % of service exports) of Sri Lanka?
Ensure brevity in your answer.  -5.87. In the year 2012, what is the difference between the Balance of Payment (as % of service exports) of Lebanon and Balance of Payment (as % of service exports) of Malaysia?
Your response must be concise. -15.46. In the year 2012, what is the difference between the Balance of Payment (as % of service exports) in Lebanon and Balance of Payment (as % of service exports) in Sri Lanka?
Give a very brief answer. 10.66. In the year 2012, what is the difference between the Balance of Payment (as % of service exports) in Malaysia and Balance of Payment (as % of service exports) in Sri Lanka?
Make the answer very short. 26.12. What is the ratio of the Balance of Payment (as % of service exports) of Cameroon in 2006 to that in 2007?
Provide a short and direct response. 1.08. What is the ratio of the Balance of Payment (as % of service exports) in Lebanon in 2006 to that in 2007?
Your answer should be compact. 1.04. What is the ratio of the Balance of Payment (as % of service exports) in Malaysia in 2006 to that in 2007?
Give a very brief answer. 1.02. What is the ratio of the Balance of Payment (as % of service exports) of Sri Lanka in 2006 to that in 2007?
Offer a very short reply. 1.16. What is the ratio of the Balance of Payment (as % of service exports) in Cameroon in 2006 to that in 2008?
Ensure brevity in your answer.  1.7. What is the ratio of the Balance of Payment (as % of service exports) of Lebanon in 2006 to that in 2008?
Your answer should be compact. 1.29. What is the ratio of the Balance of Payment (as % of service exports) in Malaysia in 2006 to that in 2008?
Your response must be concise. 0.99. What is the ratio of the Balance of Payment (as % of service exports) in Sri Lanka in 2006 to that in 2008?
Offer a very short reply. 1.48. What is the ratio of the Balance of Payment (as % of service exports) in Cameroon in 2006 to that in 2009?
Give a very brief answer. 0.82. What is the ratio of the Balance of Payment (as % of service exports) of Lebanon in 2006 to that in 2009?
Make the answer very short. 1.07. What is the ratio of the Balance of Payment (as % of service exports) of Malaysia in 2006 to that in 2009?
Your response must be concise. 0.89. What is the ratio of the Balance of Payment (as % of service exports) in Sri Lanka in 2006 to that in 2009?
Your response must be concise. 1.37. What is the ratio of the Balance of Payment (as % of service exports) in Cameroon in 2006 to that in 2010?
Ensure brevity in your answer.  1.45. What is the ratio of the Balance of Payment (as % of service exports) in Lebanon in 2006 to that in 2010?
Your answer should be very brief. 0.87. What is the ratio of the Balance of Payment (as % of service exports) of Malaysia in 2006 to that in 2010?
Provide a succinct answer. 0.87. What is the ratio of the Balance of Payment (as % of service exports) of Sri Lanka in 2006 to that in 2010?
Offer a very short reply. 1.08. What is the ratio of the Balance of Payment (as % of service exports) of Cameroon in 2006 to that in 2011?
Your response must be concise. 0.81. What is the ratio of the Balance of Payment (as % of service exports) in Lebanon in 2006 to that in 2011?
Keep it short and to the point. 1.28. What is the ratio of the Balance of Payment (as % of service exports) of Malaysia in 2006 to that in 2011?
Offer a very short reply. 0.91. What is the ratio of the Balance of Payment (as % of service exports) of Sri Lanka in 2006 to that in 2011?
Provide a succinct answer. 0.94. What is the ratio of the Balance of Payment (as % of service exports) of Cameroon in 2006 to that in 2012?
Ensure brevity in your answer.  0.83. What is the ratio of the Balance of Payment (as % of service exports) of Lebanon in 2006 to that in 2012?
Make the answer very short. 1.12. What is the ratio of the Balance of Payment (as % of service exports) of Malaysia in 2006 to that in 2012?
Keep it short and to the point. 0.93. What is the ratio of the Balance of Payment (as % of service exports) in Sri Lanka in 2006 to that in 2012?
Provide a succinct answer. 0.92. What is the ratio of the Balance of Payment (as % of service exports) in Cameroon in 2007 to that in 2008?
Provide a short and direct response. 1.57. What is the ratio of the Balance of Payment (as % of service exports) in Lebanon in 2007 to that in 2008?
Provide a succinct answer. 1.24. What is the ratio of the Balance of Payment (as % of service exports) in Malaysia in 2007 to that in 2008?
Offer a very short reply. 0.97. What is the ratio of the Balance of Payment (as % of service exports) in Sri Lanka in 2007 to that in 2008?
Offer a terse response. 1.27. What is the ratio of the Balance of Payment (as % of service exports) of Cameroon in 2007 to that in 2009?
Your answer should be very brief. 0.76. What is the ratio of the Balance of Payment (as % of service exports) of Lebanon in 2007 to that in 2009?
Offer a very short reply. 1.02. What is the ratio of the Balance of Payment (as % of service exports) of Malaysia in 2007 to that in 2009?
Provide a short and direct response. 0.87. What is the ratio of the Balance of Payment (as % of service exports) of Sri Lanka in 2007 to that in 2009?
Your answer should be compact. 1.18. What is the ratio of the Balance of Payment (as % of service exports) of Cameroon in 2007 to that in 2010?
Make the answer very short. 1.34. What is the ratio of the Balance of Payment (as % of service exports) of Lebanon in 2007 to that in 2010?
Your answer should be compact. 0.83. What is the ratio of the Balance of Payment (as % of service exports) of Malaysia in 2007 to that in 2010?
Offer a terse response. 0.85. What is the ratio of the Balance of Payment (as % of service exports) of Sri Lanka in 2007 to that in 2010?
Provide a short and direct response. 0.93. What is the ratio of the Balance of Payment (as % of service exports) of Cameroon in 2007 to that in 2011?
Your answer should be compact. 0.75. What is the ratio of the Balance of Payment (as % of service exports) in Lebanon in 2007 to that in 2011?
Give a very brief answer. 1.23. What is the ratio of the Balance of Payment (as % of service exports) of Sri Lanka in 2007 to that in 2011?
Give a very brief answer. 0.81. What is the ratio of the Balance of Payment (as % of service exports) in Cameroon in 2007 to that in 2012?
Make the answer very short. 0.77. What is the ratio of the Balance of Payment (as % of service exports) in Lebanon in 2007 to that in 2012?
Make the answer very short. 1.08. What is the ratio of the Balance of Payment (as % of service exports) in Malaysia in 2007 to that in 2012?
Offer a very short reply. 0.9. What is the ratio of the Balance of Payment (as % of service exports) of Sri Lanka in 2007 to that in 2012?
Your answer should be very brief. 0.79. What is the ratio of the Balance of Payment (as % of service exports) in Cameroon in 2008 to that in 2009?
Your answer should be compact. 0.49. What is the ratio of the Balance of Payment (as % of service exports) of Lebanon in 2008 to that in 2009?
Your response must be concise. 0.82. What is the ratio of the Balance of Payment (as % of service exports) of Malaysia in 2008 to that in 2009?
Keep it short and to the point. 0.89. What is the ratio of the Balance of Payment (as % of service exports) in Sri Lanka in 2008 to that in 2009?
Offer a terse response. 0.92. What is the ratio of the Balance of Payment (as % of service exports) of Cameroon in 2008 to that in 2010?
Provide a succinct answer. 0.85. What is the ratio of the Balance of Payment (as % of service exports) of Lebanon in 2008 to that in 2010?
Your response must be concise. 0.67. What is the ratio of the Balance of Payment (as % of service exports) of Malaysia in 2008 to that in 2010?
Give a very brief answer. 0.88. What is the ratio of the Balance of Payment (as % of service exports) of Sri Lanka in 2008 to that in 2010?
Offer a very short reply. 0.73. What is the ratio of the Balance of Payment (as % of service exports) in Cameroon in 2008 to that in 2011?
Ensure brevity in your answer.  0.48. What is the ratio of the Balance of Payment (as % of service exports) in Lebanon in 2008 to that in 2011?
Your answer should be very brief. 0.99. What is the ratio of the Balance of Payment (as % of service exports) in Malaysia in 2008 to that in 2011?
Give a very brief answer. 0.91. What is the ratio of the Balance of Payment (as % of service exports) in Sri Lanka in 2008 to that in 2011?
Provide a succinct answer. 0.63. What is the ratio of the Balance of Payment (as % of service exports) in Cameroon in 2008 to that in 2012?
Offer a terse response. 0.49. What is the ratio of the Balance of Payment (as % of service exports) of Lebanon in 2008 to that in 2012?
Your answer should be compact. 0.87. What is the ratio of the Balance of Payment (as % of service exports) in Malaysia in 2008 to that in 2012?
Provide a succinct answer. 0.93. What is the ratio of the Balance of Payment (as % of service exports) of Sri Lanka in 2008 to that in 2012?
Provide a succinct answer. 0.62. What is the ratio of the Balance of Payment (as % of service exports) of Cameroon in 2009 to that in 2010?
Your response must be concise. 1.76. What is the ratio of the Balance of Payment (as % of service exports) of Lebanon in 2009 to that in 2010?
Provide a short and direct response. 0.82. What is the ratio of the Balance of Payment (as % of service exports) of Malaysia in 2009 to that in 2010?
Your response must be concise. 0.98. What is the ratio of the Balance of Payment (as % of service exports) in Sri Lanka in 2009 to that in 2010?
Your answer should be compact. 0.79. What is the ratio of the Balance of Payment (as % of service exports) in Cameroon in 2009 to that in 2011?
Give a very brief answer. 0.98. What is the ratio of the Balance of Payment (as % of service exports) of Lebanon in 2009 to that in 2011?
Offer a very short reply. 1.2. What is the ratio of the Balance of Payment (as % of service exports) in Malaysia in 2009 to that in 2011?
Provide a short and direct response. 1.03. What is the ratio of the Balance of Payment (as % of service exports) in Sri Lanka in 2009 to that in 2011?
Make the answer very short. 0.69. What is the ratio of the Balance of Payment (as % of service exports) of Lebanon in 2009 to that in 2012?
Make the answer very short. 1.05. What is the ratio of the Balance of Payment (as % of service exports) in Malaysia in 2009 to that in 2012?
Provide a succinct answer. 1.04. What is the ratio of the Balance of Payment (as % of service exports) in Sri Lanka in 2009 to that in 2012?
Keep it short and to the point. 0.68. What is the ratio of the Balance of Payment (as % of service exports) in Cameroon in 2010 to that in 2011?
Keep it short and to the point. 0.56. What is the ratio of the Balance of Payment (as % of service exports) in Lebanon in 2010 to that in 2011?
Provide a succinct answer. 1.47. What is the ratio of the Balance of Payment (as % of service exports) of Malaysia in 2010 to that in 2011?
Give a very brief answer. 1.04. What is the ratio of the Balance of Payment (as % of service exports) of Sri Lanka in 2010 to that in 2011?
Provide a succinct answer. 0.86. What is the ratio of the Balance of Payment (as % of service exports) of Cameroon in 2010 to that in 2012?
Offer a very short reply. 0.57. What is the ratio of the Balance of Payment (as % of service exports) in Lebanon in 2010 to that in 2012?
Provide a succinct answer. 1.29. What is the ratio of the Balance of Payment (as % of service exports) in Malaysia in 2010 to that in 2012?
Give a very brief answer. 1.06. What is the ratio of the Balance of Payment (as % of service exports) of Sri Lanka in 2010 to that in 2012?
Make the answer very short. 0.85. What is the ratio of the Balance of Payment (as % of service exports) in Cameroon in 2011 to that in 2012?
Provide a short and direct response. 1.03. What is the ratio of the Balance of Payment (as % of service exports) in Lebanon in 2011 to that in 2012?
Make the answer very short. 0.88. What is the ratio of the Balance of Payment (as % of service exports) of Sri Lanka in 2011 to that in 2012?
Ensure brevity in your answer.  0.98. What is the difference between the highest and the second highest Balance of Payment (as % of service exports) of Cameroon?
Your answer should be compact. 0.41. What is the difference between the highest and the second highest Balance of Payment (as % of service exports) of Lebanon?
Ensure brevity in your answer.  6.33. What is the difference between the highest and the second highest Balance of Payment (as % of service exports) in Malaysia?
Offer a terse response. 0.85. What is the difference between the highest and the second highest Balance of Payment (as % of service exports) in Sri Lanka?
Offer a very short reply. 0.41. What is the difference between the highest and the lowest Balance of Payment (as % of service exports) in Cameroon?
Offer a very short reply. 11.51. What is the difference between the highest and the lowest Balance of Payment (as % of service exports) of Lebanon?
Make the answer very short. 16.01. What is the difference between the highest and the lowest Balance of Payment (as % of service exports) in Malaysia?
Provide a short and direct response. 8.37. What is the difference between the highest and the lowest Balance of Payment (as % of service exports) of Sri Lanka?
Offer a very short reply. 10.26. 